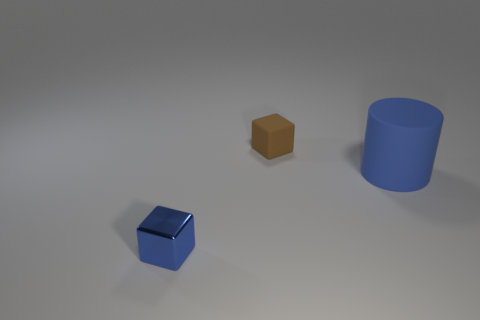Add 3 tiny cyan rubber objects. How many objects exist? 6 Subtract all cylinders. How many objects are left? 2 Add 3 tiny cubes. How many tiny cubes are left? 5 Add 1 small things. How many small things exist? 3 Subtract 0 cyan blocks. How many objects are left? 3 Subtract all small rubber cubes. Subtract all tiny rubber things. How many objects are left? 1 